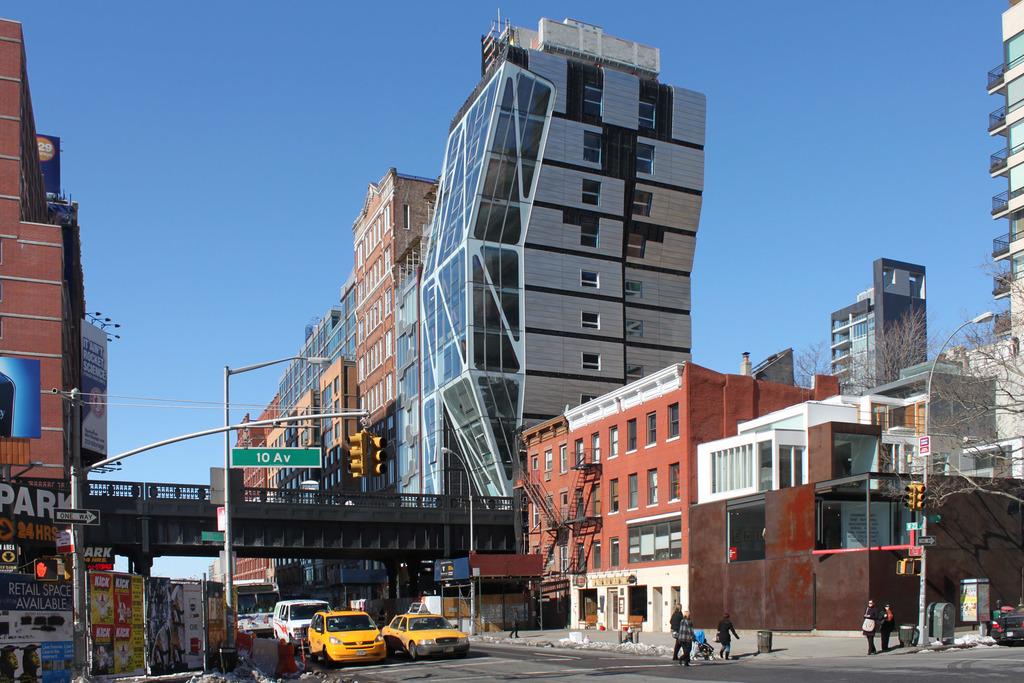What is the street name?
Offer a terse response. 10 av. What is being advertised on the sign to the left of the street sign?
Provide a short and direct response. Kick. 